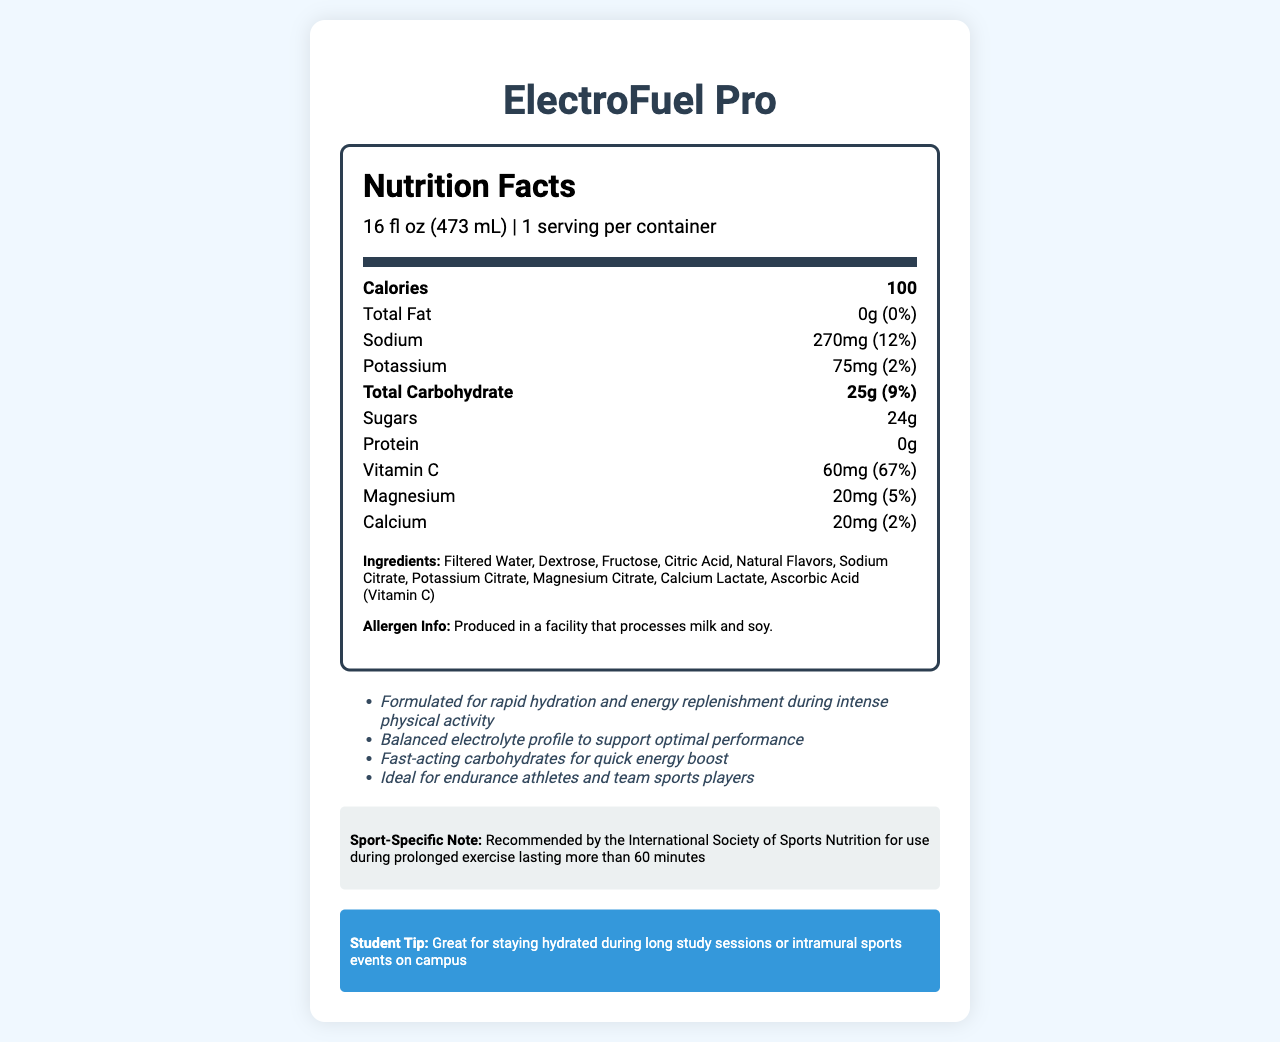what is the serving size for ElectroFuel Pro? The serving size is listed at the top of the Nutrition Facts section.
Answer: 16 fl oz (473 mL) how many servings are there per container? The document indicates there is 1 serving per container, located below the serving size.
Answer: 1 how many calories are in one serving? The number of calories per serving is shown prominently at the top of the Nutrition Facts section.
Answer: 100 calories how much sodium is in a serving of this sports drink? The amount of sodium is listed in the nutrient rows after the calories section.
Answer: 270mg what is the percentage of the daily value for Vitamin C in one serving? The daily value percentage for Vitamin C is shown next to its amount in the document.
Answer: 67% which ingredient is listed first? The first ingredient in the list is Filtered Water.
Answer: Filtered Water how much sugar is present in a serving? The amount of sugar is listed under the carbohydrate section in the nutrient rows.
Answer: 24g how much potassium does one serving contain? The potassium content is listed along with its daily value percentage in the nutrient rows.
Answer: 75mg how many grams of protein does ElectroFuel Pro have per serving? The protein content is listed as 0g in the nutrient rows.
Answer: 0g what is the primary purpose of ElectroFuel Pro according to the additional information? The additional information section explains that it is formulated for rapid hydration and energy replenishment during intense physical activity.
Answer: For rapid hydration and energy replenishment during intense physical activity the sports drink contains how much magnesium per serving? The magnesium content per serving is listed in the nutrient rows.
Answer: 20mg which of the following is NOT an ingredient in ElectroFuel Pro? A. Sodium Citrate B. Sucrose C. Ascorbic Acid Sucrose is not listed among the ingredients; Sodium Citrate and Ascorbic Acid are.
Answer: B what is the recommended use of ElectroFuel Pro according to the sport-specific note? A. Daily consumption B. During prolonged exercise lasting more than 60 minutes C. Before bedtime The sport-specific note mentions it is recommended for use during prolonged exercise lasting more than 60 minutes.
Answer: B is ElectroFuel Pro suitable for those looking to boost protein intake? ElectroFuel Pro contains 0g of protein, making it unsuitable for those looking to boost protein intake.
Answer: No summarize the main content of the document. The document offers comprehensive nutritional information for ElectroFuel Pro, emphasizing its electrolyte balance and carbohydrate content, making it beneficial for athletes during prolonged activities.
Answer: The document provides detailed Nutrition Facts for ElectroFuel Pro, a sports drink designed for optimal hydration and energy replenishment. It lists nutrient amounts, ingredient details, recommended use, and allergen information. It highlights key nutrients like sodium, potassium, vitamin C, and carbohydrates while pointing out that it's ideal for endurance athletes and suitable during extended physical exertion. how does the sodium content in ElectroFuel Pro compare to its daily value percentage? The sodium content is 270mg, which corresponds to 12% of the daily value.
Answer: It is 12% of the daily value. what facility processes the drink, and what allergens might cross-contaminate? The allergen information specifies that ElectroFuel Pro is produced in a facility that processes milk and soy.
Answer: A facility that processes milk and soy describe the type of carbohydrates present in ElectroFuel Pro. The additional information states that it contains fast-acting carbohydrates designed to provide a quick energy boost.
Answer: Fast-acting carbohydrates for quick energy boost does the document provide specific information on the color of the sports drink? The document does not provide any details on the color of the sports drink.
Answer: Cannot be determined 